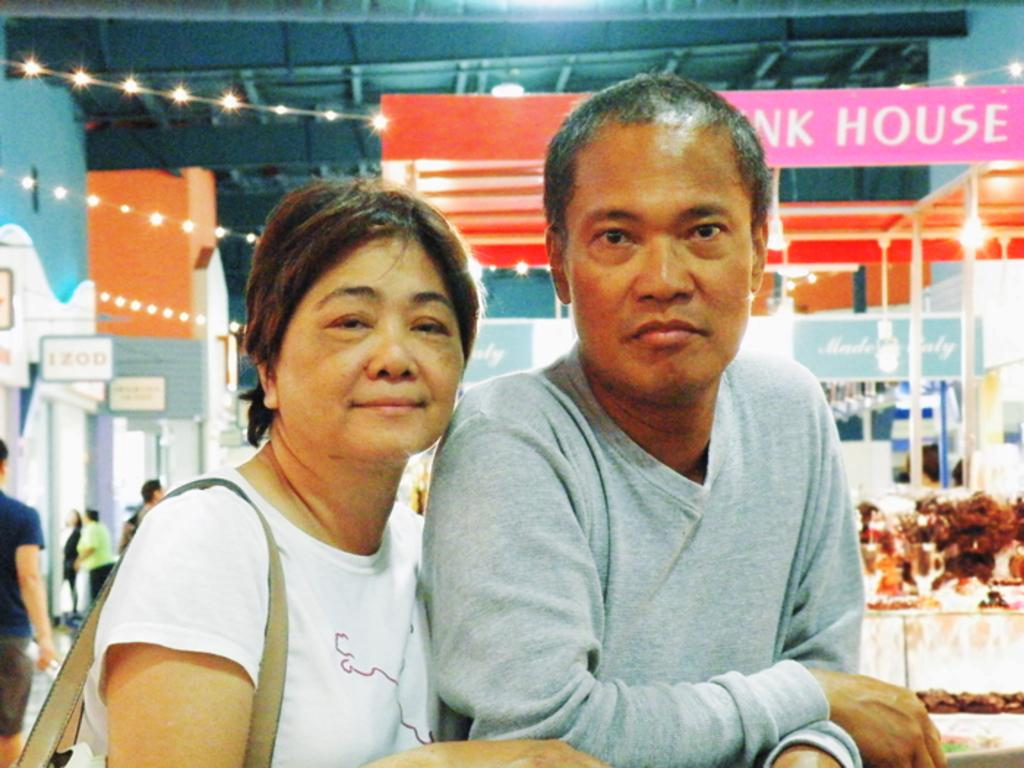How many people are present in the image? There is a man and a woman in the image, making a total of two people. What can be seen in the background of the image? In the background of the image, there are people, name boards, lights, and some objects. Can you describe the objects in the background of the image? Unfortunately, the provided facts do not specify the nature of the objects in the background. What type of lighting is visible in the background of the image? The facts do not specify the type of lighting, only that lights are visible in the background. What type of insect can be seen crawling in the man's pocket in the image? There is no insect visible in the man's pocket in the image, as the provided facts do not mention any insects. 